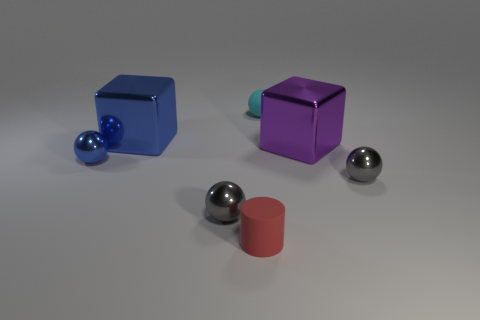Are there any tiny objects that have the same color as the small rubber ball?
Ensure brevity in your answer.  No. What number of tiny metal spheres have the same color as the matte ball?
Offer a terse response. 0. Is the number of large metal cubes that are to the left of the small cyan thing less than the number of big metal blocks?
Provide a succinct answer. Yes. The small metal sphere that is right of the rubber thing on the right side of the tiny red matte cylinder is what color?
Make the answer very short. Gray. How big is the blue thing on the right side of the small blue thing in front of the object behind the blue shiny block?
Offer a terse response. Large. Is the number of big blocks that are to the left of the purple metal thing less than the number of blue blocks behind the matte sphere?
Offer a very short reply. No. How many small gray things are the same material as the large blue thing?
Your response must be concise. 2. Are there any blue blocks on the right side of the small cyan rubber thing to the right of the metal cube behind the big purple object?
Offer a terse response. No. There is a thing that is made of the same material as the red cylinder; what shape is it?
Provide a short and direct response. Sphere. Are there more gray metallic cylinders than small cyan rubber balls?
Your response must be concise. No. 